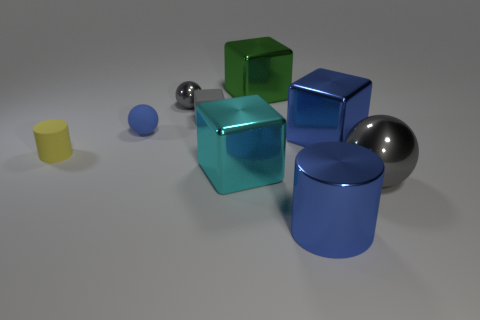What material is the tiny thing that is the same color as the matte block?
Keep it short and to the point. Metal. What shape is the blue object that is in front of the gray thing that is to the right of the gray block?
Your response must be concise. Cylinder. What number of gray objects are made of the same material as the yellow cylinder?
Offer a very short reply. 1. There is a big sphere that is the same material as the big blue block; what color is it?
Make the answer very short. Gray. What is the size of the metal thing that is behind the gray shiny sphere that is left of the gray ball in front of the small yellow rubber object?
Keep it short and to the point. Large. Is the number of large green rubber spheres less than the number of tiny cubes?
Your response must be concise. Yes. What color is the other tiny thing that is the same shape as the small blue object?
Provide a short and direct response. Gray. There is a metallic ball behind the big cube that is in front of the small matte cylinder; is there a large metallic block that is on the left side of it?
Provide a short and direct response. No. Is the shape of the cyan metal object the same as the small yellow rubber object?
Provide a succinct answer. No. Are there fewer matte cubes that are in front of the small rubber sphere than big balls?
Provide a succinct answer. Yes. 